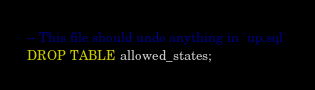Convert code to text. <code><loc_0><loc_0><loc_500><loc_500><_SQL_>-- This file should undo anything in `up.sql`
DROP TABLE allowed_states;</code> 